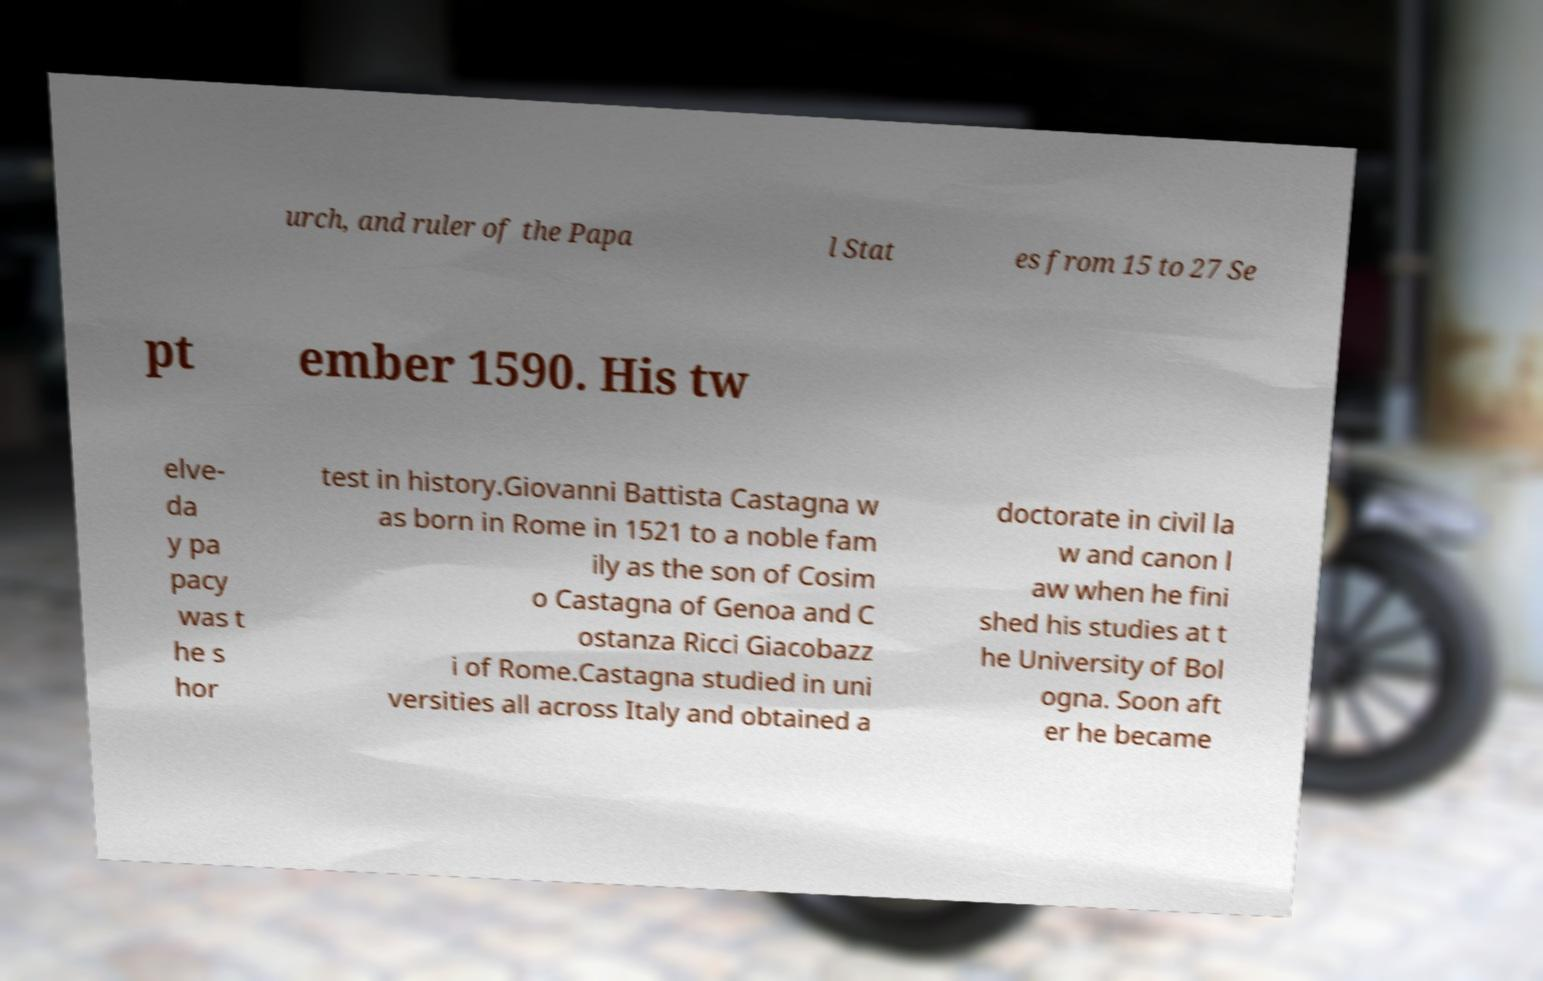What messages or text are displayed in this image? I need them in a readable, typed format. urch, and ruler of the Papa l Stat es from 15 to 27 Se pt ember 1590. His tw elve- da y pa pacy was t he s hor test in history.Giovanni Battista Castagna w as born in Rome in 1521 to a noble fam ily as the son of Cosim o Castagna of Genoa and C ostanza Ricci Giacobazz i of Rome.Castagna studied in uni versities all across Italy and obtained a doctorate in civil la w and canon l aw when he fini shed his studies at t he University of Bol ogna. Soon aft er he became 